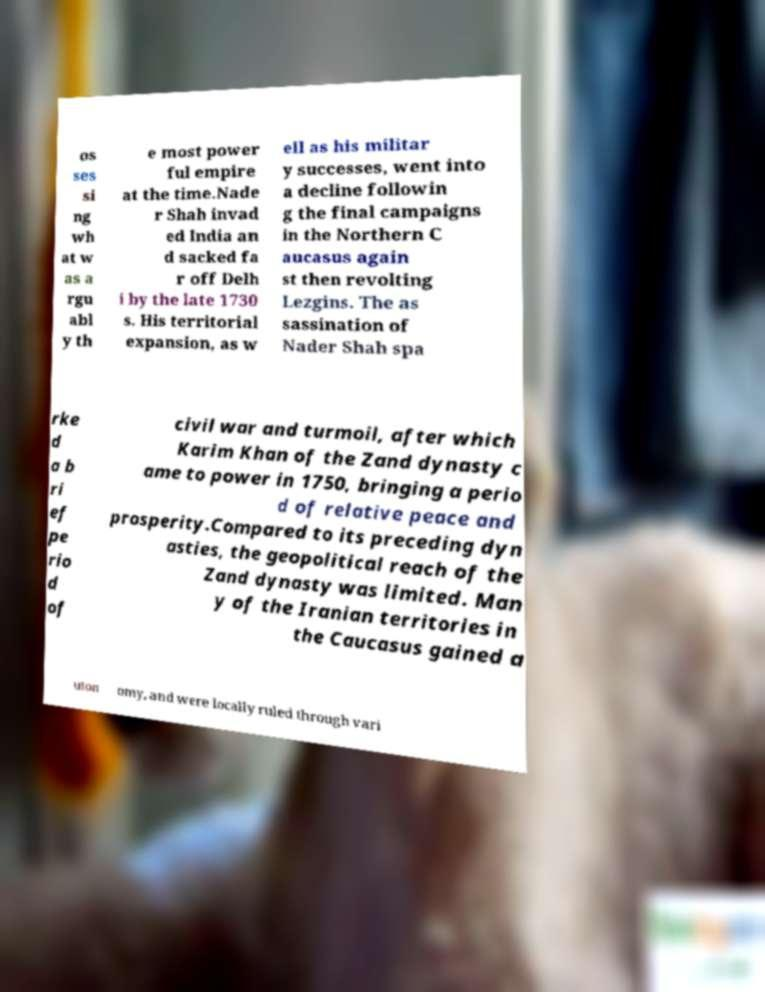Could you extract and type out the text from this image? os ses si ng wh at w as a rgu abl y th e most power ful empire at the time.Nade r Shah invad ed India an d sacked fa r off Delh i by the late 1730 s. His territorial expansion, as w ell as his militar y successes, went into a decline followin g the final campaigns in the Northern C aucasus again st then revolting Lezgins. The as sassination of Nader Shah spa rke d a b ri ef pe rio d of civil war and turmoil, after which Karim Khan of the Zand dynasty c ame to power in 1750, bringing a perio d of relative peace and prosperity.Compared to its preceding dyn asties, the geopolitical reach of the Zand dynasty was limited. Man y of the Iranian territories in the Caucasus gained a uton omy, and were locally ruled through vari 